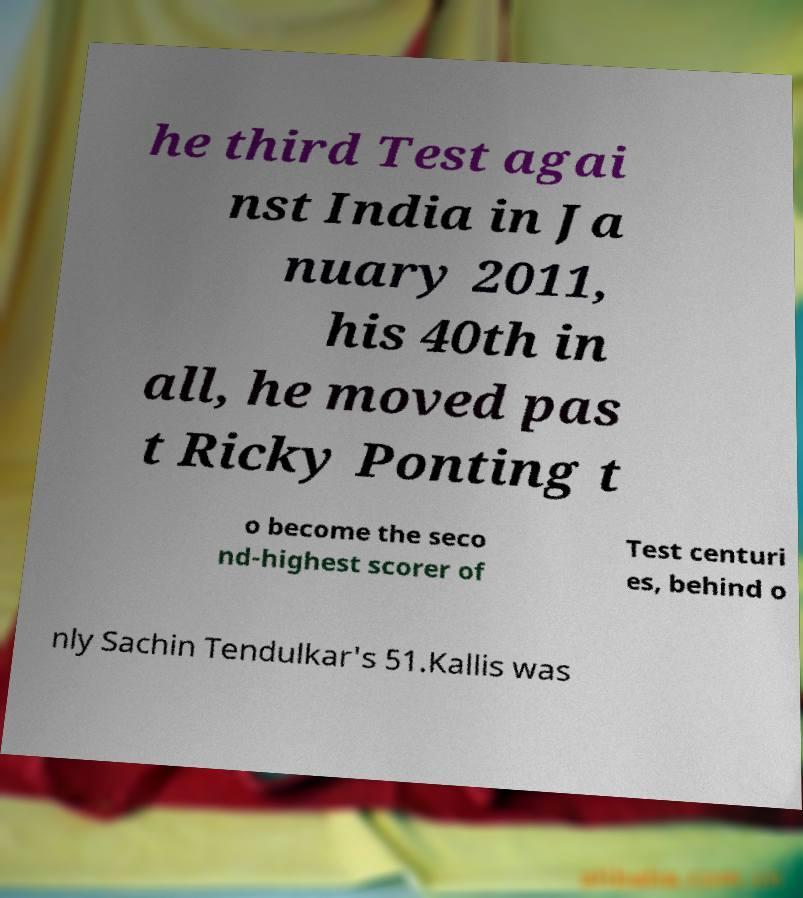Could you assist in decoding the text presented in this image and type it out clearly? he third Test agai nst India in Ja nuary 2011, his 40th in all, he moved pas t Ricky Ponting t o become the seco nd-highest scorer of Test centuri es, behind o nly Sachin Tendulkar's 51.Kallis was 